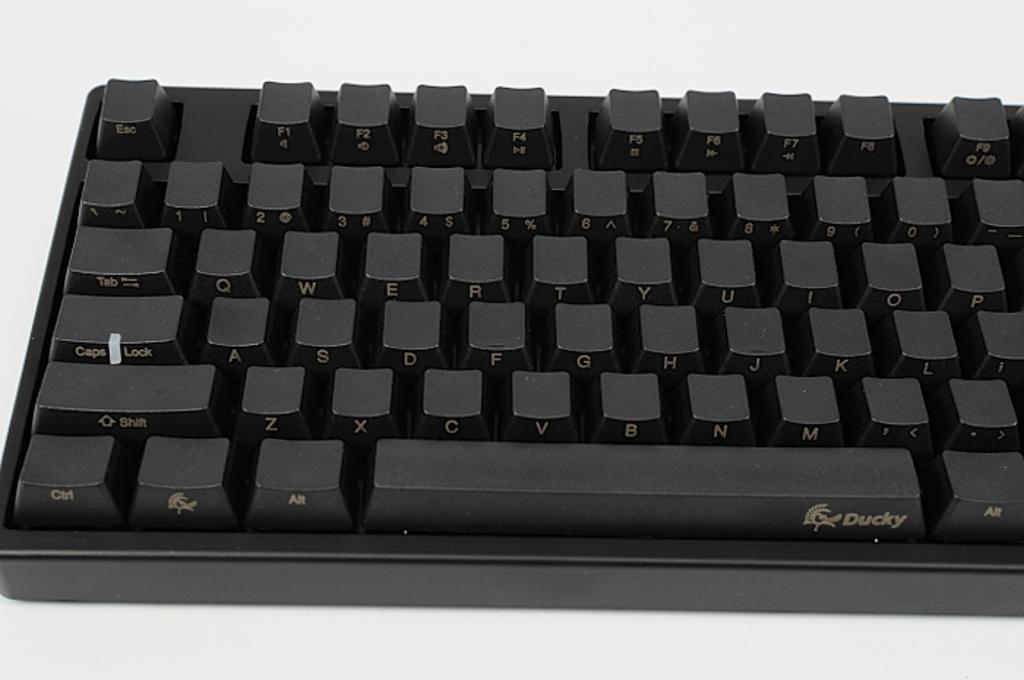What is the make of keyboard?
Your answer should be compact. Ducky. What key is  the bottom right key?
Provide a short and direct response. Alt. 